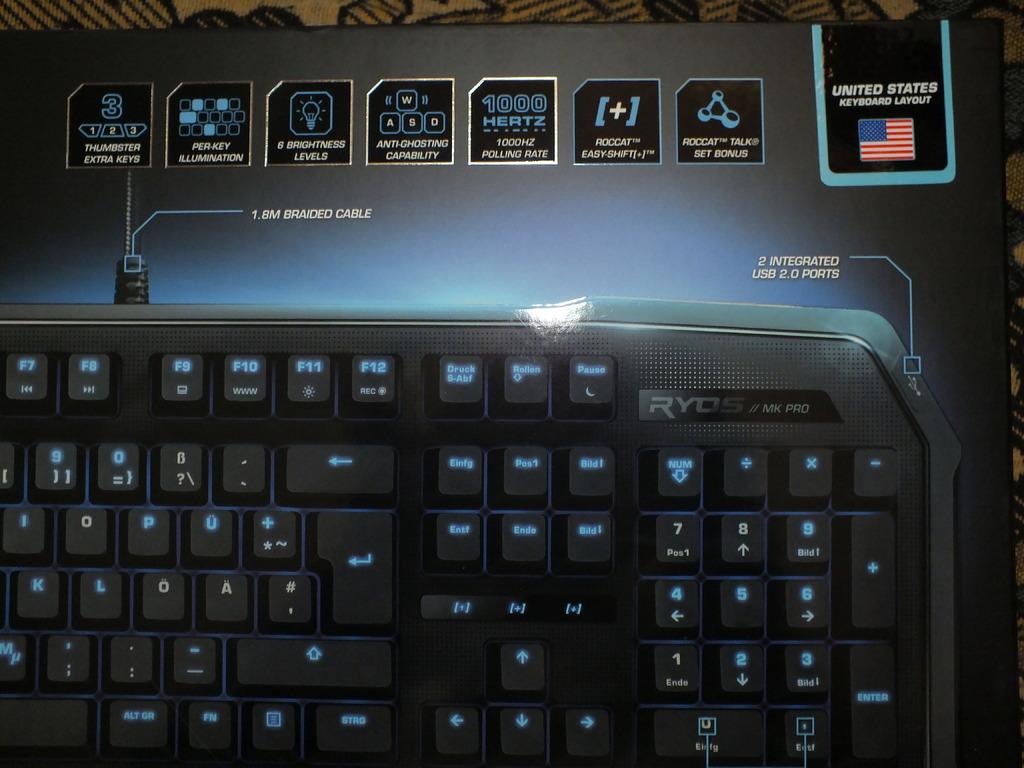What brand of keyboard is that?
Keep it short and to the point. Ryos. Which country's flag is on the keyboard?
Offer a terse response. United states. 